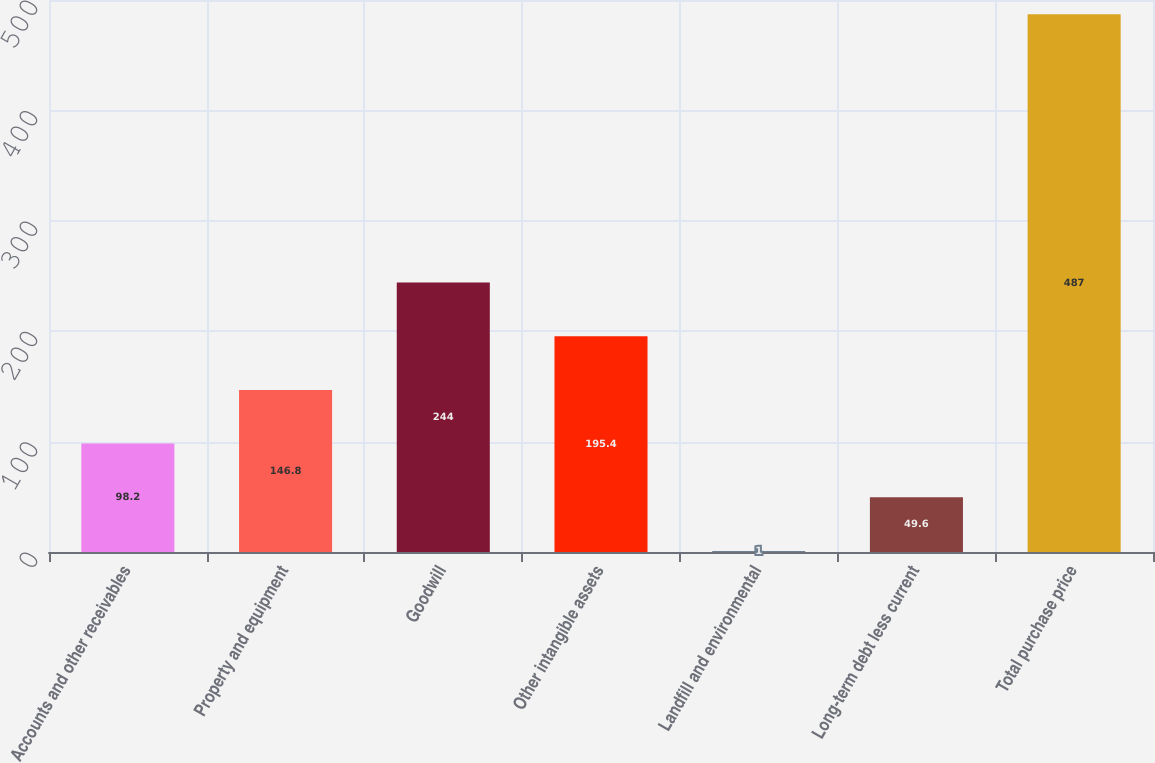Convert chart. <chart><loc_0><loc_0><loc_500><loc_500><bar_chart><fcel>Accounts and other receivables<fcel>Property and equipment<fcel>Goodwill<fcel>Other intangible assets<fcel>Landfill and environmental<fcel>Long-term debt less current<fcel>Total purchase price<nl><fcel>98.2<fcel>146.8<fcel>244<fcel>195.4<fcel>1<fcel>49.6<fcel>487<nl></chart> 